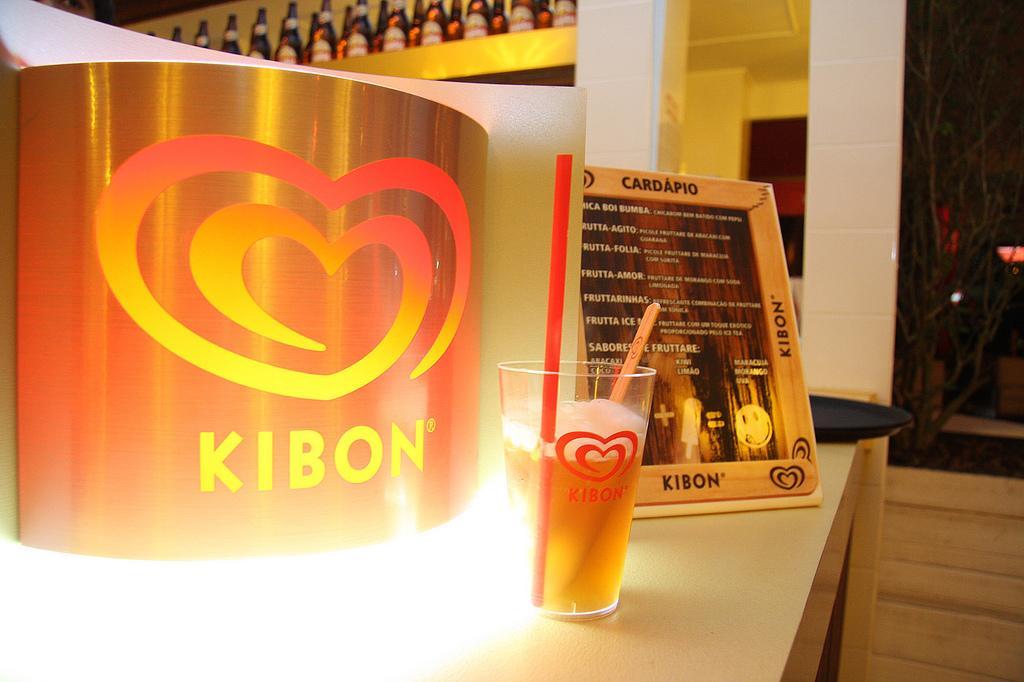Describe this image in one or two sentences. In this picture I can see few bottles and I can see a glass with a straw and I can see a frame with some text on the table and I can see a tray on the side. 